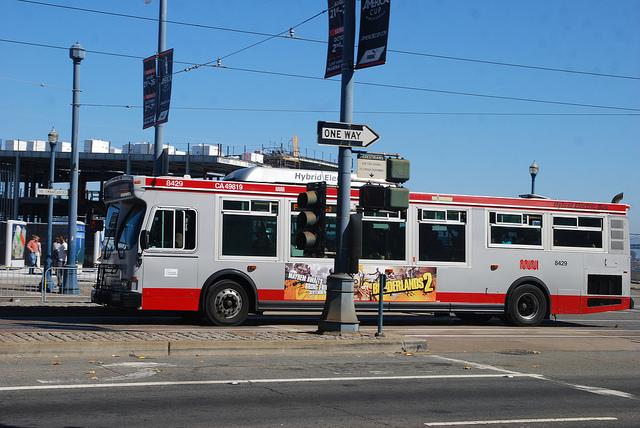What type of company paid to have their product advertised on the bus? video game 